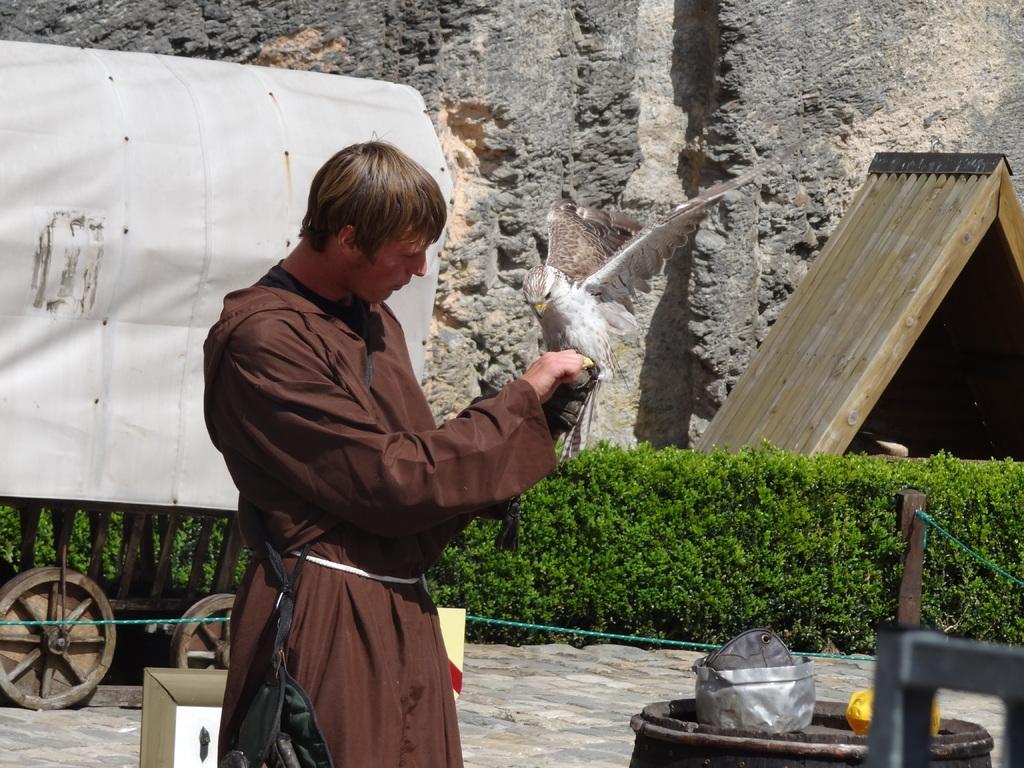Describe this image in one or two sentences. In this image we can see a person, and a bird on his hand, there is a kart, board, plants, there are objects on the barrel, there is a wooden pole, rope, also we can see the wall. 